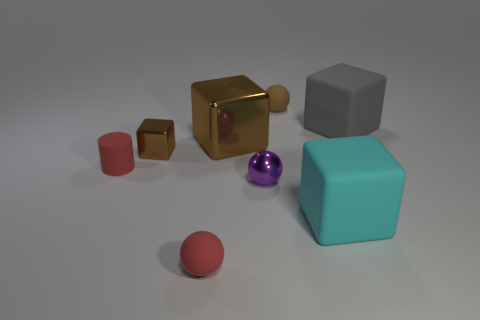Do the tiny brown object right of the large shiny thing and the big gray rubber object have the same shape?
Your answer should be compact. No. What number of gray objects are the same shape as the small brown rubber object?
Your answer should be very brief. 0. Is there a gray cube made of the same material as the cylinder?
Your answer should be very brief. Yes. What material is the brown block that is left of the big brown thing that is to the left of the large gray matte thing?
Offer a terse response. Metal. How big is the rubber sphere that is behind the tiny brown metallic thing?
Make the answer very short. Small. There is a tiny block; is it the same color as the small rubber ball behind the small cylinder?
Give a very brief answer. Yes. Is there a object that has the same color as the tiny cylinder?
Keep it short and to the point. Yes. Is the material of the brown sphere the same as the purple object that is in front of the big shiny block?
Keep it short and to the point. No. What number of tiny things are cyan blocks or metallic objects?
Keep it short and to the point. 2. There is another cube that is the same color as the big metal block; what is its material?
Keep it short and to the point. Metal. 